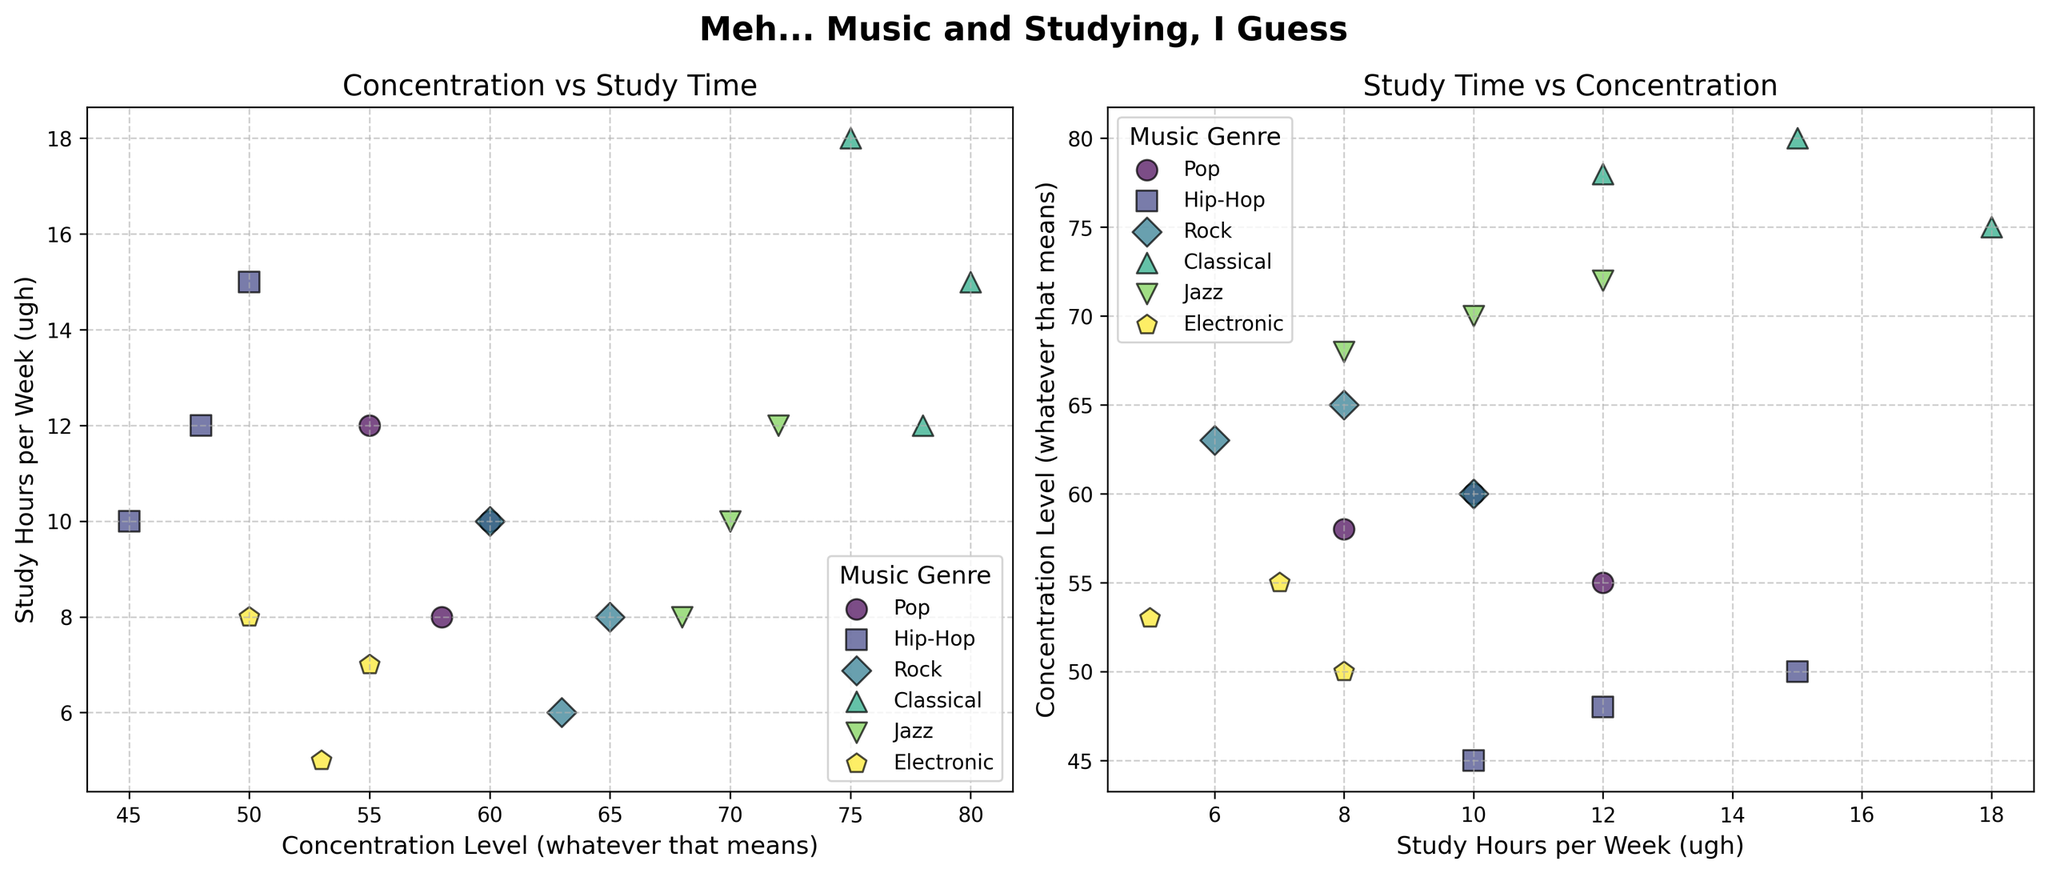What's the title of the figure? The title of the figure is located at the top, and it reads "Meh... Music and Studying, I Guess." This title suggests a casual or indifferent attitude toward the content of the plot.
Answer: Meh... Music and Studying, I Guess Which music genre seems to have the highest average concentration level? To find the highest average concentration level, look at the data points for each genre. Classical music has the highest concentration levels, with values of 80, 78, and 75.
Answer: Classical How many data points are shown for each music genre? Count the number of data points for each genre. Each genre has 3 data points on the scatter plot.
Answer: 3 Between Pop and Rock, which genre shows higher concentration levels? Identify the data points for Pop and Rock and compare their concentration levels. Pop has concentration levels of 60, 55, and 58, while Rock has levels of 65, 60, and 63. Rock has higher concentration levels.
Answer: Rock What's the concentration level for Classical music with 12 study hours per week? Find the data point where Classical music intersects with 12 study hours on the x-axis. The concentration level is 78.
Answer: 78 How does the concentration level generally relate to study hours per week for Classical music? Examine the trend for Classical music. As study hours increase, concentration levels seem to decrease slightly, but remain relatively high.
Answer: Decreases slightly, but remains high Which genre has the lowest concentration levels overall? Compare the concentration levels across all genres. Hip-Hop has the lowest concentration levels, with values of 50, 45, and 48.
Answer: Hip-Hop What's the average concentration level for Jazz music? Calculate the average for Jazz concentration levels: (70 + 68 + 72) / 3 = 70.
Answer: 70 How many total study hours per week are recorded for Electronic music? Sum up the study hours for Electronic music: 7 + 5 + 8 = 20.
Answer: 20 Which genre has study hours that mostly fall below 10 per week? Look at the study hours for each genre. Electronic music primarily has study hours below 10 (7, 5, and 8).
Answer: Electronic 